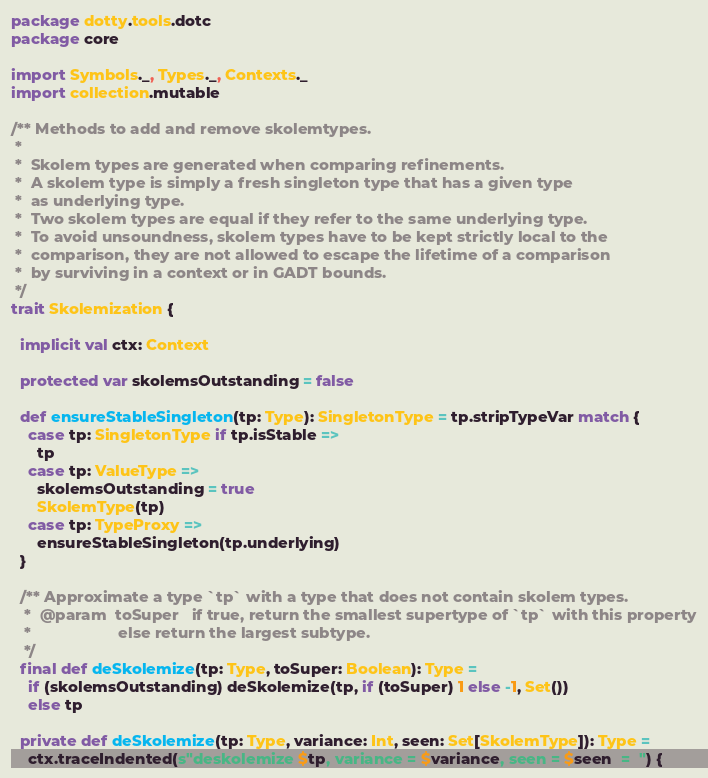Convert code to text. <code><loc_0><loc_0><loc_500><loc_500><_Scala_>package dotty.tools.dotc
package core

import Symbols._, Types._, Contexts._
import collection.mutable

/** Methods to add and remove skolemtypes.
 *  
 *  Skolem types are generated when comparing refinements. 
 *  A skolem type is simply a fresh singleton type that has a given type
 *  as underlying type.
 *  Two skolem types are equal if they refer to the same underlying type. 
 *  To avoid unsoundness, skolem types have to be kept strictly local to the
 *  comparison, they are not allowed to escape the lifetime of a comparison
 *  by surviving in a context or in GADT bounds. 
 */
trait Skolemization {
  
  implicit val ctx: Context

  protected var skolemsOutstanding = false
  
  def ensureStableSingleton(tp: Type): SingletonType = tp.stripTypeVar match {
    case tp: SingletonType if tp.isStable => 
      tp
    case tp: ValueType => 
      skolemsOutstanding = true
      SkolemType(tp)
    case tp: TypeProxy => 
      ensureStableSingleton(tp.underlying)
  }
    
  /** Approximate a type `tp` with a type that does not contain skolem types.
   *  @param  toSuper   if true, return the smallest supertype of `tp` with this property
   *                    else return the largest subtype.
   */
  final def deSkolemize(tp: Type, toSuper: Boolean): Type = 
    if (skolemsOutstanding) deSkolemize(tp, if (toSuper) 1 else -1, Set()) 
    else tp

  private def deSkolemize(tp: Type, variance: Int, seen: Set[SkolemType]): Type =
    ctx.traceIndented(s"deskolemize $tp, variance = $variance, seen = $seen  =  ") {</code> 